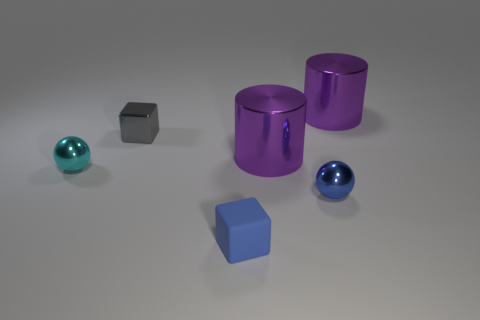There is a small thing to the left of the gray thing behind the tiny rubber cube in front of the tiny gray metallic object; what is its shape?
Provide a short and direct response. Sphere. How many blue balls are on the left side of the small cyan metallic ball?
Keep it short and to the point. 0. Does the small ball right of the rubber object have the same material as the tiny gray thing?
Your answer should be compact. Yes. What number of metal cubes are behind the big purple metallic cylinder that is to the left of the small metal object in front of the small cyan sphere?
Provide a short and direct response. 1. The small ball that is to the left of the small gray block is what color?
Offer a very short reply. Cyan. There is a large metallic cylinder that is behind the gray object; is it the same color as the matte cube?
Your answer should be compact. No. The other thing that is the same shape as the tiny gray metallic thing is what size?
Offer a terse response. Small. Are there any other things that have the same size as the gray metal thing?
Ensure brevity in your answer.  Yes. The tiny blue object that is in front of the ball that is in front of the small metal ball that is to the left of the gray object is made of what material?
Provide a short and direct response. Rubber. Is the number of small cyan shiny things that are on the right side of the small metallic cube greater than the number of cylinders right of the rubber block?
Offer a very short reply. No. 